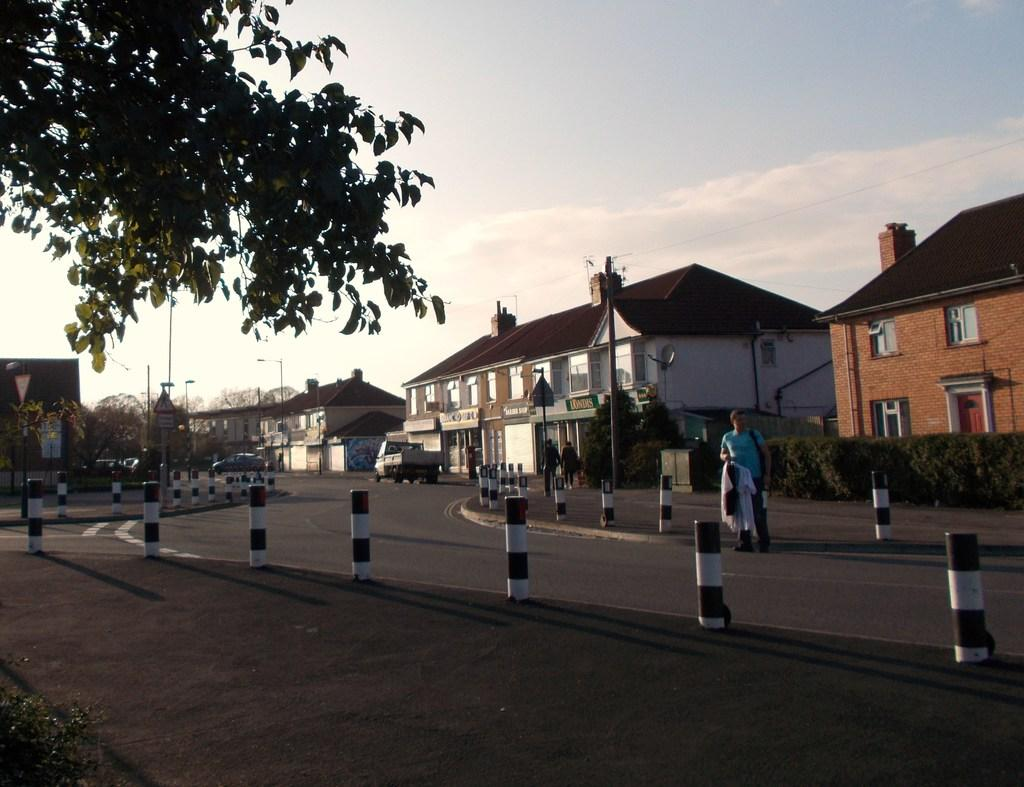What type of natural elements can be seen in the image? There are trees in the image. What man-made structures are present in the image? There are poles, boards, buildings, and vehicles in the image. What is the condition of the sky in the image? The sky is cloudy in the image. What type of surface is visible in the image? There is a road in the image. Are there any people present in the image? Yes, there are people in the image. What are the vehicles doing in the image? Vehicles are on the road in the image. What additional objects can be seen in the image? There are rods and other objects in the image. Is there any interaction between people and objects in the image? Yes, a person is holding an object in the image. Can you tell me how many holes are visible in the image? There are no holes present in the image. What type of tooth is being exchanged between the people in the image? There is no tooth exchange happening in the image; people are not interacting with teeth. 